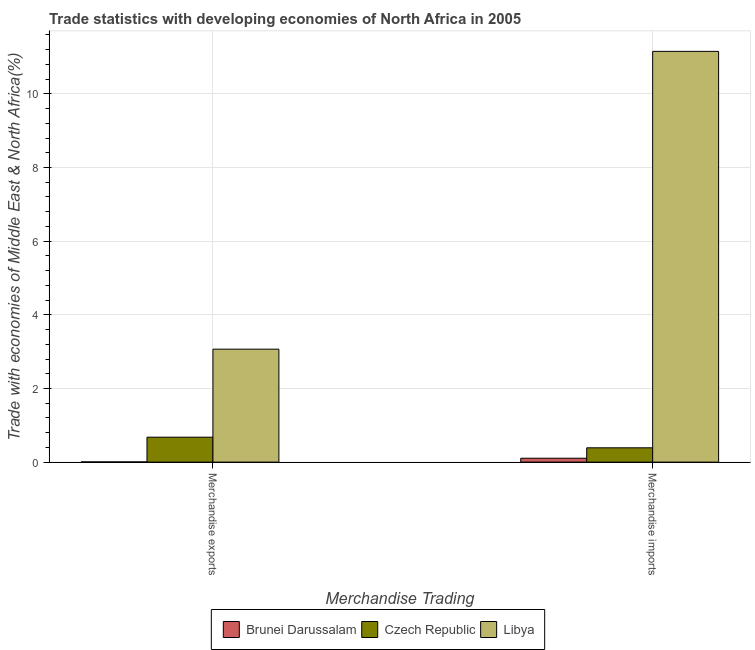How many different coloured bars are there?
Your answer should be compact. 3. How many groups of bars are there?
Keep it short and to the point. 2. Are the number of bars per tick equal to the number of legend labels?
Provide a short and direct response. Yes. How many bars are there on the 2nd tick from the right?
Keep it short and to the point. 3. What is the label of the 1st group of bars from the left?
Offer a terse response. Merchandise exports. What is the merchandise imports in Czech Republic?
Give a very brief answer. 0.39. Across all countries, what is the maximum merchandise imports?
Offer a very short reply. 11.15. Across all countries, what is the minimum merchandise exports?
Your answer should be compact. 0.01. In which country was the merchandise imports maximum?
Offer a terse response. Libya. In which country was the merchandise exports minimum?
Give a very brief answer. Brunei Darussalam. What is the total merchandise exports in the graph?
Offer a terse response. 3.75. What is the difference between the merchandise imports in Czech Republic and that in Libya?
Ensure brevity in your answer.  -10.77. What is the difference between the merchandise exports in Czech Republic and the merchandise imports in Libya?
Your answer should be compact. -10.48. What is the average merchandise imports per country?
Provide a succinct answer. 3.88. What is the difference between the merchandise imports and merchandise exports in Brunei Darussalam?
Provide a succinct answer. 0.1. In how many countries, is the merchandise exports greater than 4.8 %?
Provide a short and direct response. 0. What is the ratio of the merchandise exports in Libya to that in Czech Republic?
Offer a very short reply. 4.53. In how many countries, is the merchandise exports greater than the average merchandise exports taken over all countries?
Provide a short and direct response. 1. What does the 3rd bar from the left in Merchandise imports represents?
Make the answer very short. Libya. What does the 3rd bar from the right in Merchandise exports represents?
Provide a short and direct response. Brunei Darussalam. How many bars are there?
Ensure brevity in your answer.  6. How many countries are there in the graph?
Ensure brevity in your answer.  3. What is the difference between two consecutive major ticks on the Y-axis?
Offer a very short reply. 2. Does the graph contain any zero values?
Offer a terse response. No. Does the graph contain grids?
Provide a succinct answer. Yes. How many legend labels are there?
Offer a very short reply. 3. What is the title of the graph?
Provide a succinct answer. Trade statistics with developing economies of North Africa in 2005. Does "Qatar" appear as one of the legend labels in the graph?
Make the answer very short. No. What is the label or title of the X-axis?
Offer a terse response. Merchandise Trading. What is the label or title of the Y-axis?
Keep it short and to the point. Trade with economies of Middle East & North Africa(%). What is the Trade with economies of Middle East & North Africa(%) in Brunei Darussalam in Merchandise exports?
Give a very brief answer. 0.01. What is the Trade with economies of Middle East & North Africa(%) of Czech Republic in Merchandise exports?
Your answer should be compact. 0.68. What is the Trade with economies of Middle East & North Africa(%) in Libya in Merchandise exports?
Provide a succinct answer. 3.07. What is the Trade with economies of Middle East & North Africa(%) in Brunei Darussalam in Merchandise imports?
Offer a terse response. 0.11. What is the Trade with economies of Middle East & North Africa(%) of Czech Republic in Merchandise imports?
Offer a terse response. 0.39. What is the Trade with economies of Middle East & North Africa(%) in Libya in Merchandise imports?
Keep it short and to the point. 11.15. Across all Merchandise Trading, what is the maximum Trade with economies of Middle East & North Africa(%) in Brunei Darussalam?
Your response must be concise. 0.11. Across all Merchandise Trading, what is the maximum Trade with economies of Middle East & North Africa(%) in Czech Republic?
Keep it short and to the point. 0.68. Across all Merchandise Trading, what is the maximum Trade with economies of Middle East & North Africa(%) of Libya?
Keep it short and to the point. 11.15. Across all Merchandise Trading, what is the minimum Trade with economies of Middle East & North Africa(%) in Brunei Darussalam?
Give a very brief answer. 0.01. Across all Merchandise Trading, what is the minimum Trade with economies of Middle East & North Africa(%) in Czech Republic?
Your answer should be very brief. 0.39. Across all Merchandise Trading, what is the minimum Trade with economies of Middle East & North Africa(%) of Libya?
Your answer should be very brief. 3.07. What is the total Trade with economies of Middle East & North Africa(%) in Brunei Darussalam in the graph?
Your answer should be very brief. 0.11. What is the total Trade with economies of Middle East & North Africa(%) of Czech Republic in the graph?
Offer a very short reply. 1.07. What is the total Trade with economies of Middle East & North Africa(%) in Libya in the graph?
Ensure brevity in your answer.  14.22. What is the difference between the Trade with economies of Middle East & North Africa(%) in Brunei Darussalam in Merchandise exports and that in Merchandise imports?
Provide a succinct answer. -0.1. What is the difference between the Trade with economies of Middle East & North Africa(%) in Czech Republic in Merchandise exports and that in Merchandise imports?
Your answer should be very brief. 0.29. What is the difference between the Trade with economies of Middle East & North Africa(%) of Libya in Merchandise exports and that in Merchandise imports?
Ensure brevity in your answer.  -8.09. What is the difference between the Trade with economies of Middle East & North Africa(%) in Brunei Darussalam in Merchandise exports and the Trade with economies of Middle East & North Africa(%) in Czech Republic in Merchandise imports?
Make the answer very short. -0.38. What is the difference between the Trade with economies of Middle East & North Africa(%) of Brunei Darussalam in Merchandise exports and the Trade with economies of Middle East & North Africa(%) of Libya in Merchandise imports?
Ensure brevity in your answer.  -11.15. What is the difference between the Trade with economies of Middle East & North Africa(%) in Czech Republic in Merchandise exports and the Trade with economies of Middle East & North Africa(%) in Libya in Merchandise imports?
Offer a terse response. -10.48. What is the average Trade with economies of Middle East & North Africa(%) of Brunei Darussalam per Merchandise Trading?
Your response must be concise. 0.06. What is the average Trade with economies of Middle East & North Africa(%) in Czech Republic per Merchandise Trading?
Make the answer very short. 0.53. What is the average Trade with economies of Middle East & North Africa(%) in Libya per Merchandise Trading?
Offer a very short reply. 7.11. What is the difference between the Trade with economies of Middle East & North Africa(%) of Brunei Darussalam and Trade with economies of Middle East & North Africa(%) of Czech Republic in Merchandise exports?
Offer a very short reply. -0.67. What is the difference between the Trade with economies of Middle East & North Africa(%) in Brunei Darussalam and Trade with economies of Middle East & North Africa(%) in Libya in Merchandise exports?
Provide a short and direct response. -3.06. What is the difference between the Trade with economies of Middle East & North Africa(%) in Czech Republic and Trade with economies of Middle East & North Africa(%) in Libya in Merchandise exports?
Keep it short and to the point. -2.39. What is the difference between the Trade with economies of Middle East & North Africa(%) in Brunei Darussalam and Trade with economies of Middle East & North Africa(%) in Czech Republic in Merchandise imports?
Give a very brief answer. -0.28. What is the difference between the Trade with economies of Middle East & North Africa(%) of Brunei Darussalam and Trade with economies of Middle East & North Africa(%) of Libya in Merchandise imports?
Ensure brevity in your answer.  -11.05. What is the difference between the Trade with economies of Middle East & North Africa(%) in Czech Republic and Trade with economies of Middle East & North Africa(%) in Libya in Merchandise imports?
Provide a short and direct response. -10.77. What is the ratio of the Trade with economies of Middle East & North Africa(%) in Brunei Darussalam in Merchandise exports to that in Merchandise imports?
Provide a short and direct response. 0.06. What is the ratio of the Trade with economies of Middle East & North Africa(%) of Czech Republic in Merchandise exports to that in Merchandise imports?
Make the answer very short. 1.74. What is the ratio of the Trade with economies of Middle East & North Africa(%) of Libya in Merchandise exports to that in Merchandise imports?
Your answer should be very brief. 0.28. What is the difference between the highest and the second highest Trade with economies of Middle East & North Africa(%) in Brunei Darussalam?
Give a very brief answer. 0.1. What is the difference between the highest and the second highest Trade with economies of Middle East & North Africa(%) of Czech Republic?
Ensure brevity in your answer.  0.29. What is the difference between the highest and the second highest Trade with economies of Middle East & North Africa(%) of Libya?
Your response must be concise. 8.09. What is the difference between the highest and the lowest Trade with economies of Middle East & North Africa(%) in Brunei Darussalam?
Keep it short and to the point. 0.1. What is the difference between the highest and the lowest Trade with economies of Middle East & North Africa(%) in Czech Republic?
Offer a terse response. 0.29. What is the difference between the highest and the lowest Trade with economies of Middle East & North Africa(%) of Libya?
Provide a short and direct response. 8.09. 